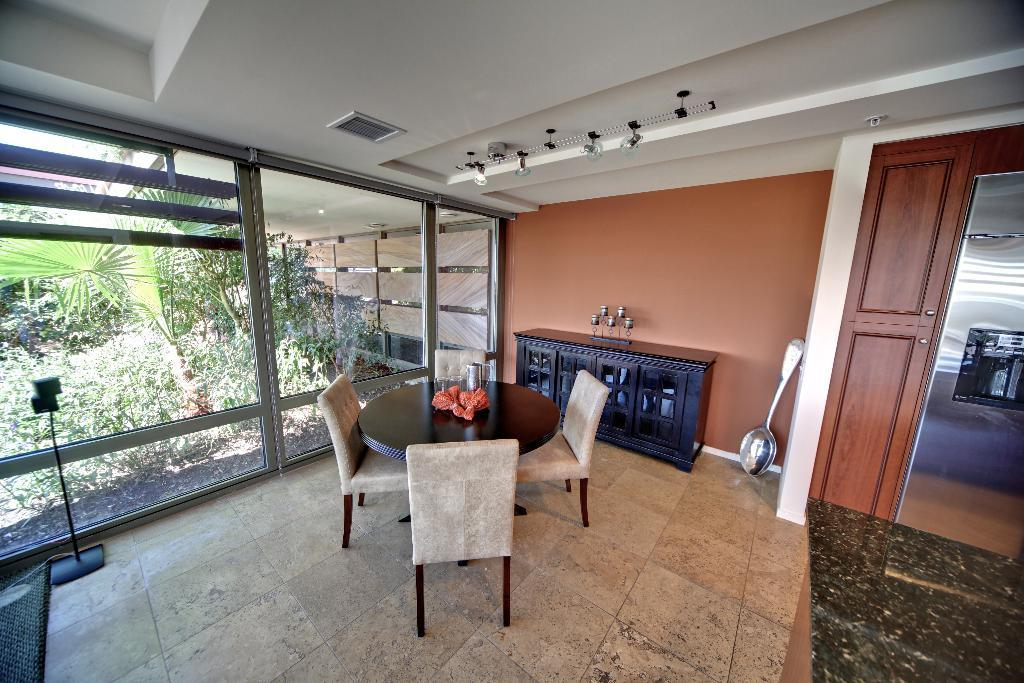What type of furniture is present in the image? There is a table and chairs in the image. What type of container can be seen in the image? There is a jar in the image. What type of storage is present in the image? There are cupboards in the image. What is on the floor in the image? There are objects on the floor in the image. What can be seen in the background of the image? There is a wall, roof, lights, glass, and trees visible through the glass in the background of the image. How much money is on the table in the image? There is no mention of money in the image; it only contains a table, chairs, a jar, cupboards, objects on the floor, a wall, roof, lights, glass, and trees visible through the glass in the background. What type of plants are growing on the chairs in the image? There are no plants growing on the chairs in the image; it only contains a table, chairs, a jar, cupboards, objects on the floor, a wall, roof, lights, glass, and trees visible through the glass in the background. 